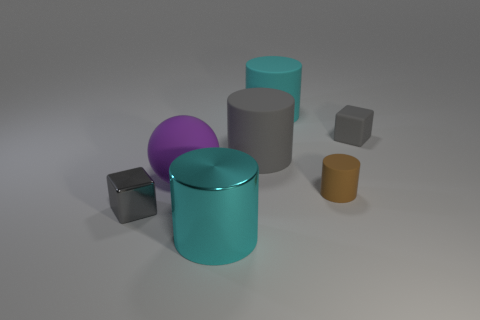Is the color of the tiny block that is to the right of the big purple ball the same as the block on the left side of the small brown object?
Provide a short and direct response. Yes. Is the number of tiny brown cylinders that are behind the small rubber block greater than the number of small yellow balls?
Your answer should be compact. No. There is a cyan thing that is in front of the big purple matte sphere that is behind the metal block; what number of objects are in front of it?
Offer a terse response. 0. There is a thing that is both right of the large purple sphere and in front of the small cylinder; what is its material?
Your answer should be very brief. Metal. The metallic cylinder has what color?
Make the answer very short. Cyan. Are there more large cyan metallic things that are right of the big rubber ball than brown cylinders behind the matte block?
Keep it short and to the point. Yes. There is a small cube behind the small gray metallic block; what color is it?
Offer a very short reply. Gray. Does the brown cylinder right of the gray cylinder have the same size as the cube left of the large gray rubber cylinder?
Your response must be concise. Yes. How many objects are large cyan matte spheres or objects?
Keep it short and to the point. 7. The block behind the shiny thing that is to the left of the big shiny cylinder is made of what material?
Your answer should be very brief. Rubber. 